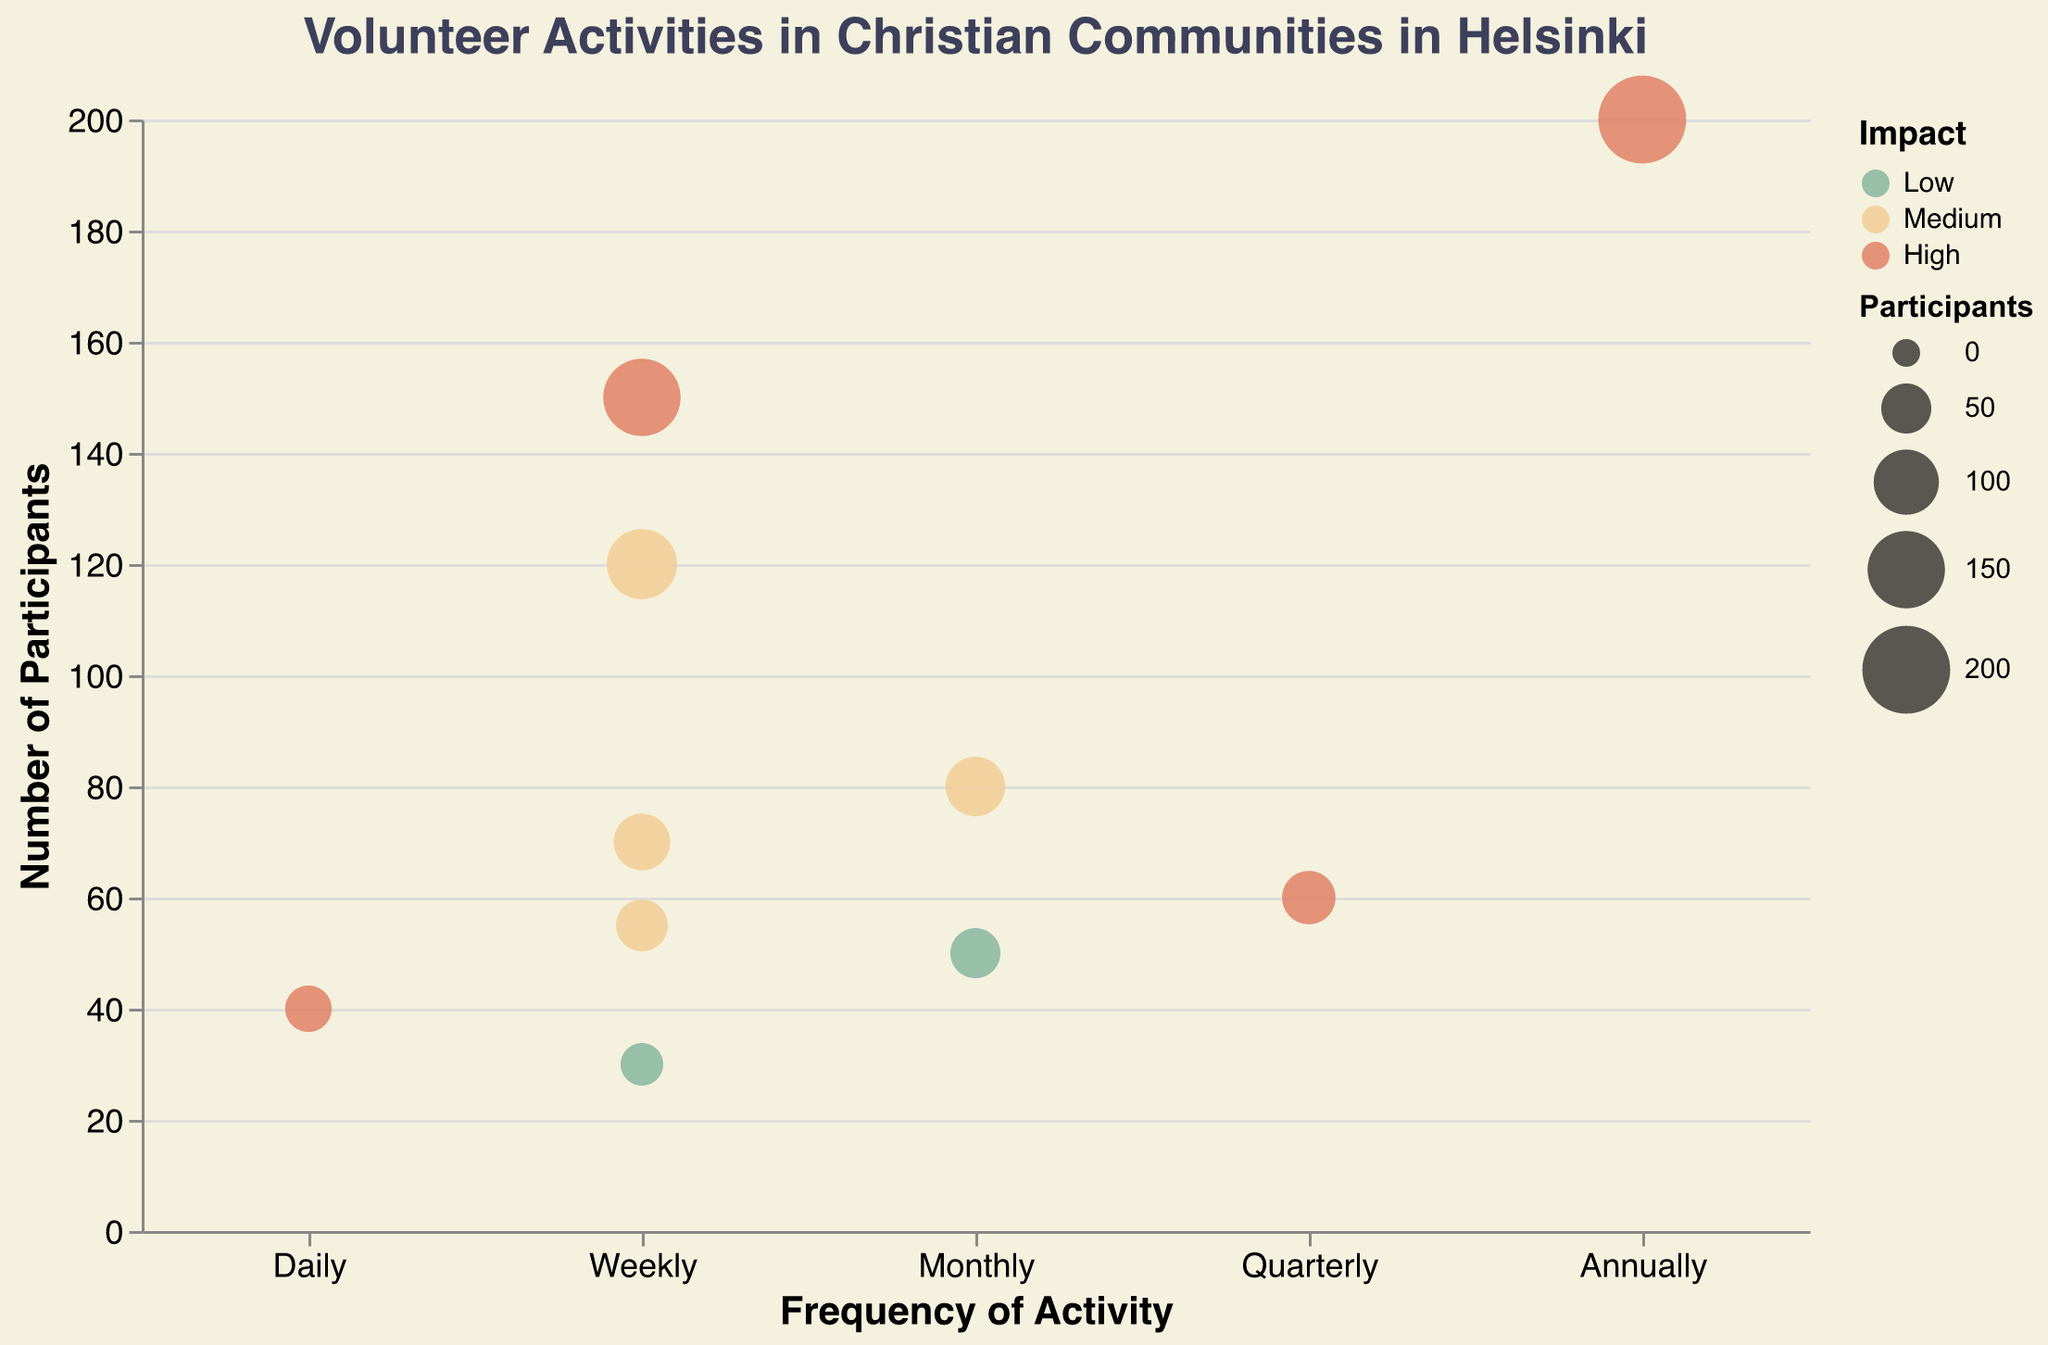What is the title of the figure? The title is displayed at the top of the figure; it reads "Volunteer Activities in Christian Communities in Helsinki."
Answer: Volunteer Activities in Christian Communities in Helsinki How many activities have a 'High' impact? By observing the color legend, 'High' impact activities are colored in a particular hue. Count the number of data points in this color.
Answer: 4 What is the activity with the highest number of participants? The y-axis represents the number of participants. Identify the bubble that is located the highest on the y-axis. Also, check the tooltip to confirm the activity.
Answer: Charity Events What activity is represented by the smallest bubble? The size of the bubbles represents the number of participants. Find the smallest bubble on the chart.
Answer: Sunday School Teaching Which activity occurs most frequently? The x-axis represents the frequency of the activities. The 'Daily' frequency is at the far left. Check which bubbles are aligned with 'Daily.'
Answer: Soup Kitchen Volunteer Which activity has the largest number of participants and is conducted weekly? Filter the bubbles on the x-axis corresponding to 'Weekly.' Then, among these, find the highest bubble on the y-axis. Confirm with the tooltip if needed.
Answer: Food Donation Compare the number of participants in the 'Clothing Donation Drive' and 'Community Clean-up.' Which has more participants? Locate the position of both activities on the chart and compare their y-axis values.
Answer: Clothing Donation Drive What is the average number of participants for weekly activities? Identify all weekly activities, sum their participants and divide by the number of weekly activities. (150 for Food Donation, 120 for Bible Study Groups, 70 for Elderly Home Visits, 30 for Sunday School Teaching, 55 for Counseling Services). The sum is 425, divided by 5.
Answer: 85 participants Is there any activity conducted quarterly? If so, what is it and how many people participate in it? Check the x-axis at 'Quarterly' frequency and find the corresponding bubble. Check the tooltip for more details.
Answer: Clothing Donation Drive, 60 participants Which activities have a 'Medium' impact? Count and identify the 'Medium' colored bubbles. Check the tooltips for confirmation.
Answer: Bible Study Groups, Youth Outreach Program, Elderly Home Visits, Counseling Services 